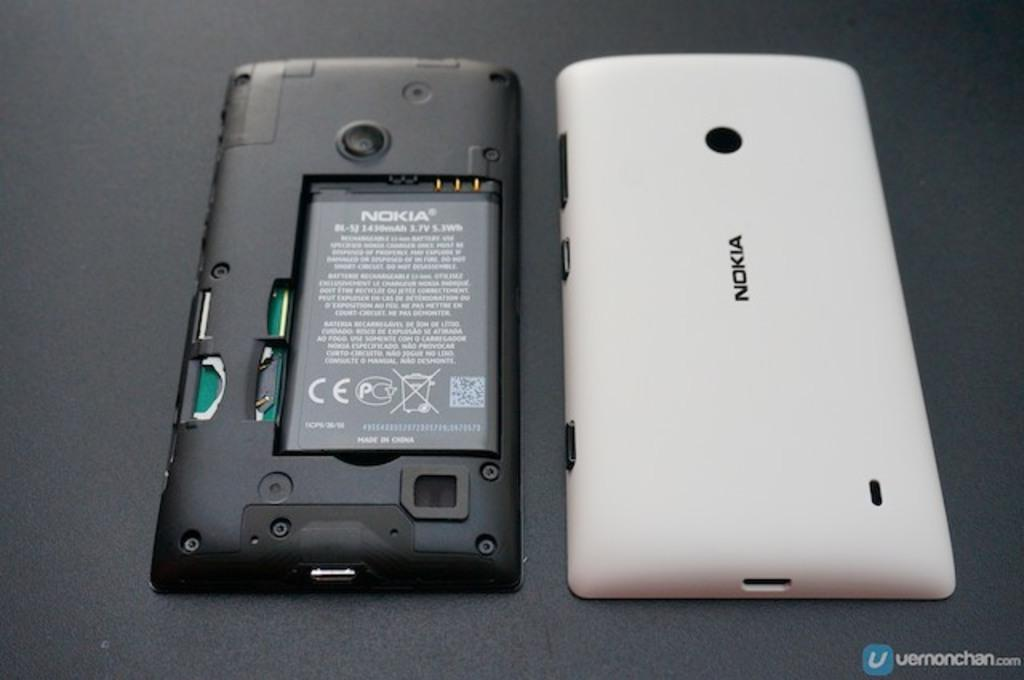<image>
Create a compact narrative representing the image presented. A phone from Nokia with the back remove and place to its side. 